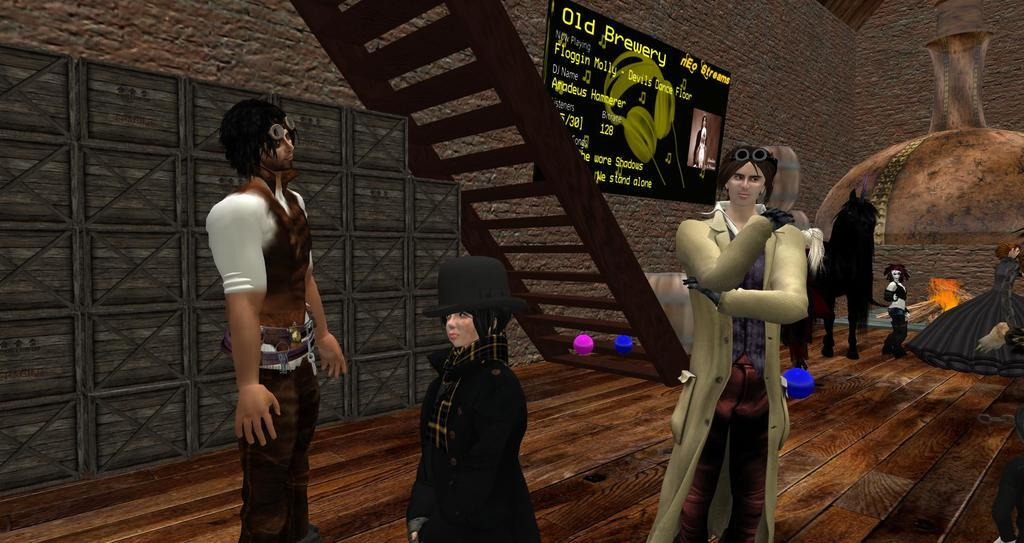What type of liquid is dripping from the map onto the person's face in the image? There is no image provided, and therefore no map, person, or liquid can be observed. 